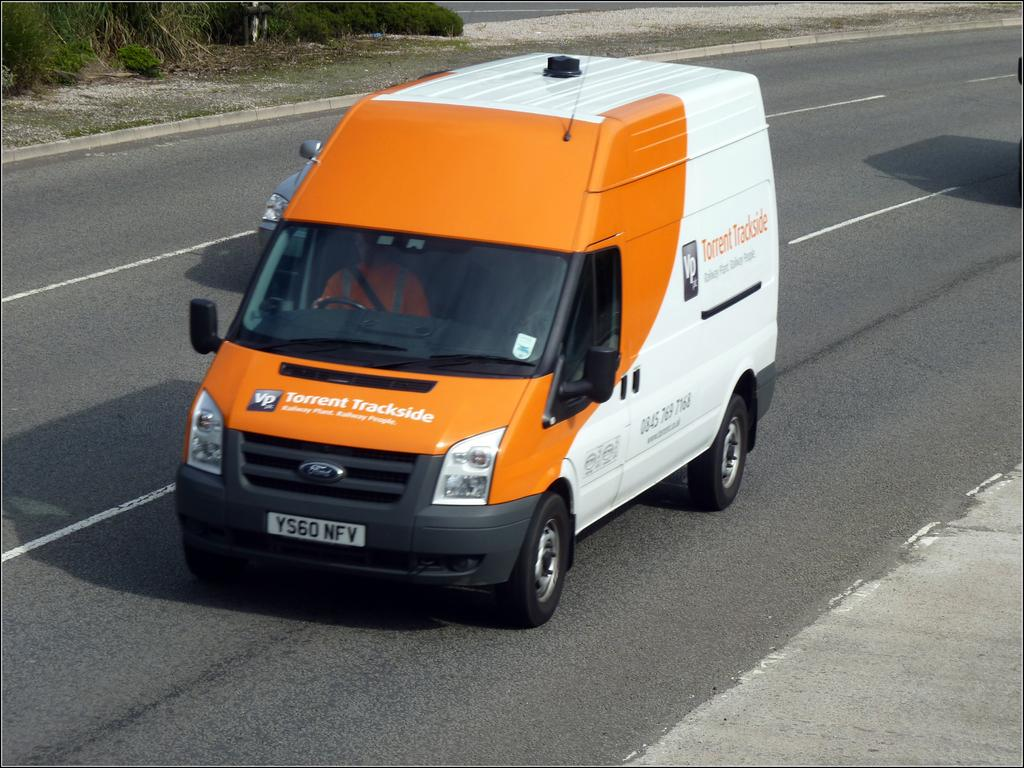<image>
Create a compact narrative representing the image presented. an orange and white van for Torrent Tracks on the road 